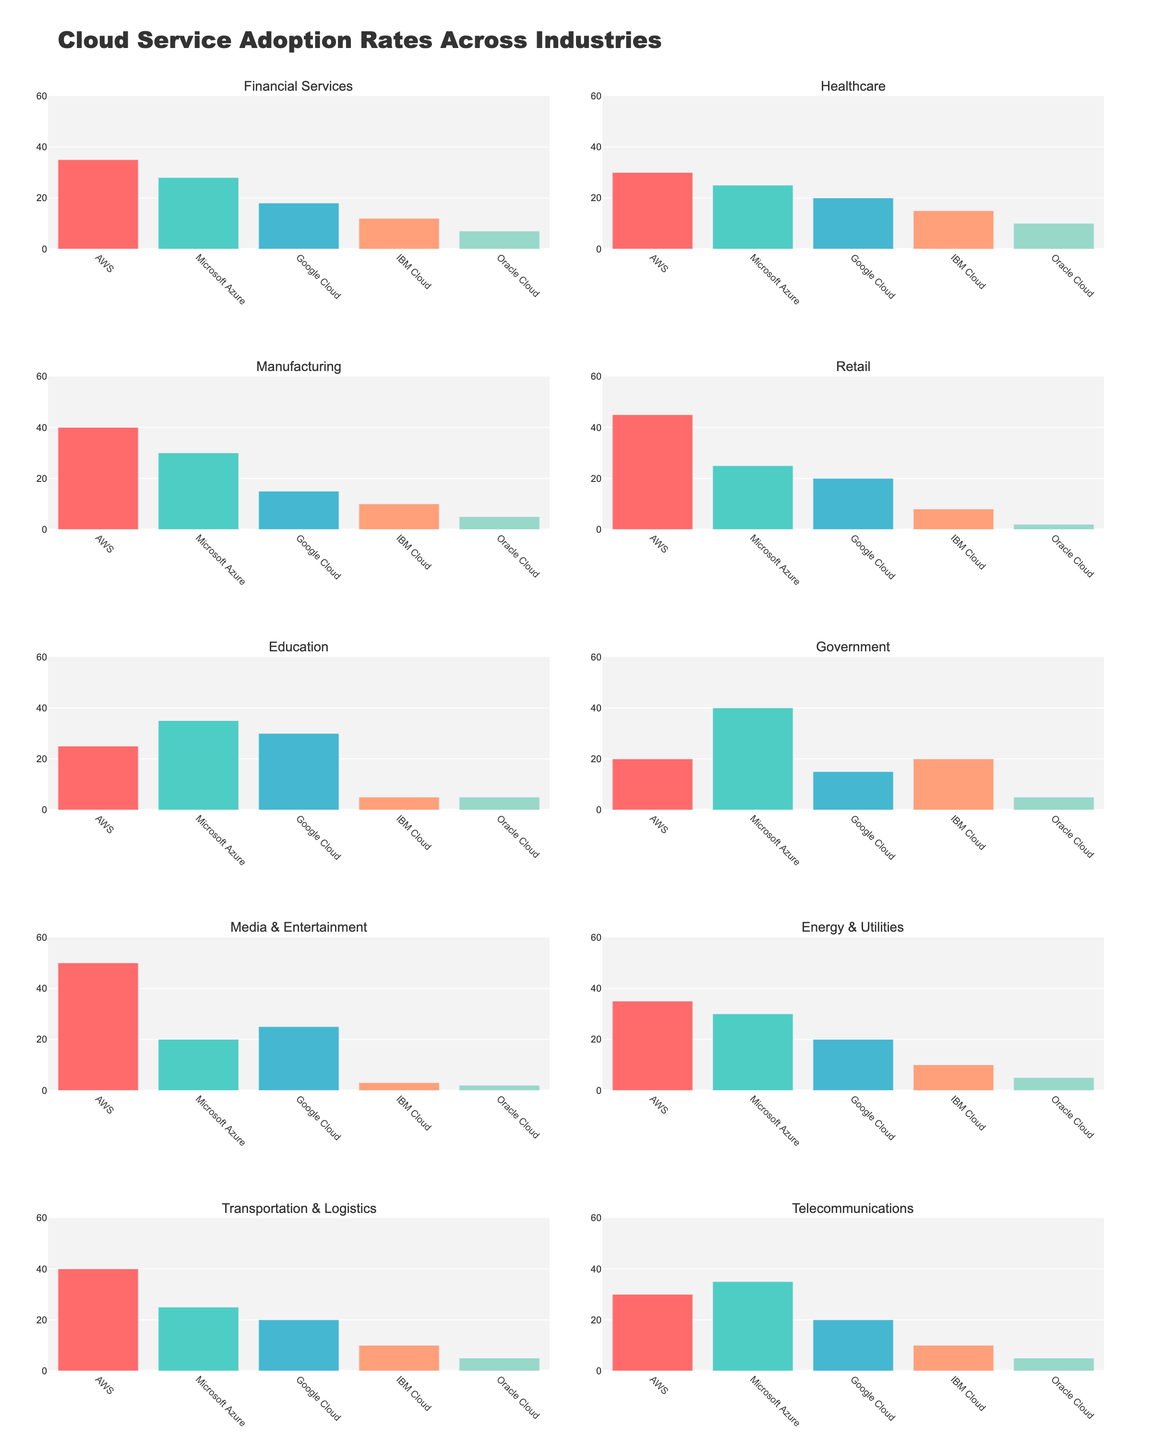Which industry has the highest adoption rate of AWS? This question requires identifying the bar with the highest value for AWS across all subplots. AWS is represented by the first bar in each subplot, and the Media & Entertainment industry shows the highest bar for AWS at 50.
Answer: Media & Entertainment What is the average adoption rate of Microsoft Azure across all industries? Find the values for Microsoft Azure in each subplot and then compute the average: (28+25+30+25+35+40+20+30+25+35)/10 = 29.3.
Answer: 29.3 Which cloud provider has the lowest adoption rate in the Retail industry? Look at the bars in the Retail industry subplot and identify the shortest bar, which corresponds to Oracle Cloud at 2.
Answer: Oracle Cloud What is the total adoption rate of all cloud providers in the Healthcare industry? Sum the heights of all bars in the Healthcare industry subplot: 30 (AWS) + 25 (Microsoft Azure) + 20 (Google Cloud) + 15 (IBM Cloud) + 10 (Oracle Cloud) = 100.
Answer: 100 Is Google Cloud more adopted in the Education or Government industry? Compare the height of Google Cloud bars in the Education and Government industry subplots. Education has a higher bar for Google Cloud at 30 compared to Government's 15.
Answer: Education What is the difference in IBM Cloud adoption rates between the Energy & Utilities and Government industries? Subtract the height of IBM Cloud bar in the Energy & Utilities subplot (10) from that in the Government subplot (20): 20 - 10 = 10.
Answer: 10 Which industry has the highest diversity in cloud service adoption rates? Identify the subplot showing the most varied heights of bars (largest difference between the highest and the lowest bars). The Education industry ranges from 35 (Microsoft Azure) to 5 (IBM Cloud and Oracle Cloud), showing the highest diversity.
Answer: Education How many industries have AWS as the most adopted cloud service? Count the subplots where the AWS bar is the highest: Financial Services, Healthcare, Manufacturing, Retail, Media & Entertainment, and Energy & Utilities.
Answer: 6 By how much does the Microsoft Azure adoption rate in the Government industry exceed that of the Financial Services industry? Subtract the height of the Microsoft Azure bar in Financial Services (28) from that in the Government (40): 40 - 28 = 12.
Answer: 12 Does the Manufacturing industry have a higher adoption rate of IBM Cloud or Oracle Cloud? Compare the heights of IBM Cloud and Oracle Cloud bars in the Manufacturing subplot. IBM Cloud has a higher value at 10, compared to Oracle Cloud’s 5.
Answer: IBM Cloud 